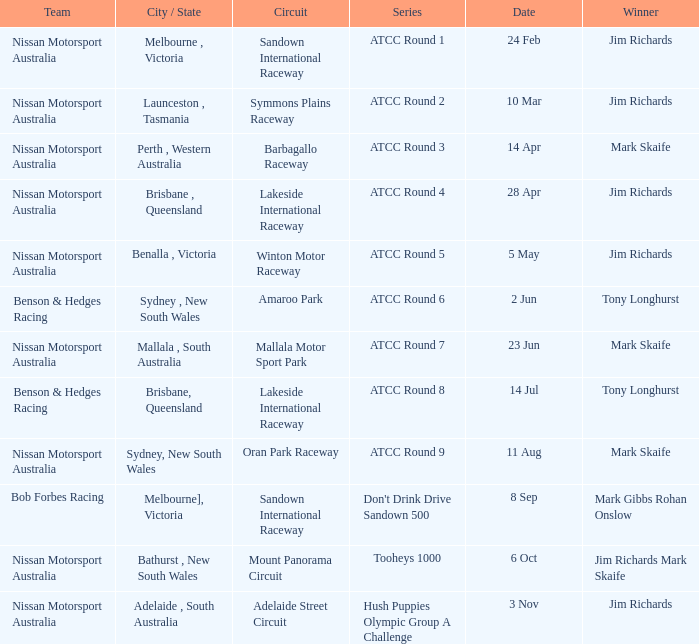What is the Team of Winner Mark Skaife in ATCC Round 7? Nissan Motorsport Australia. 